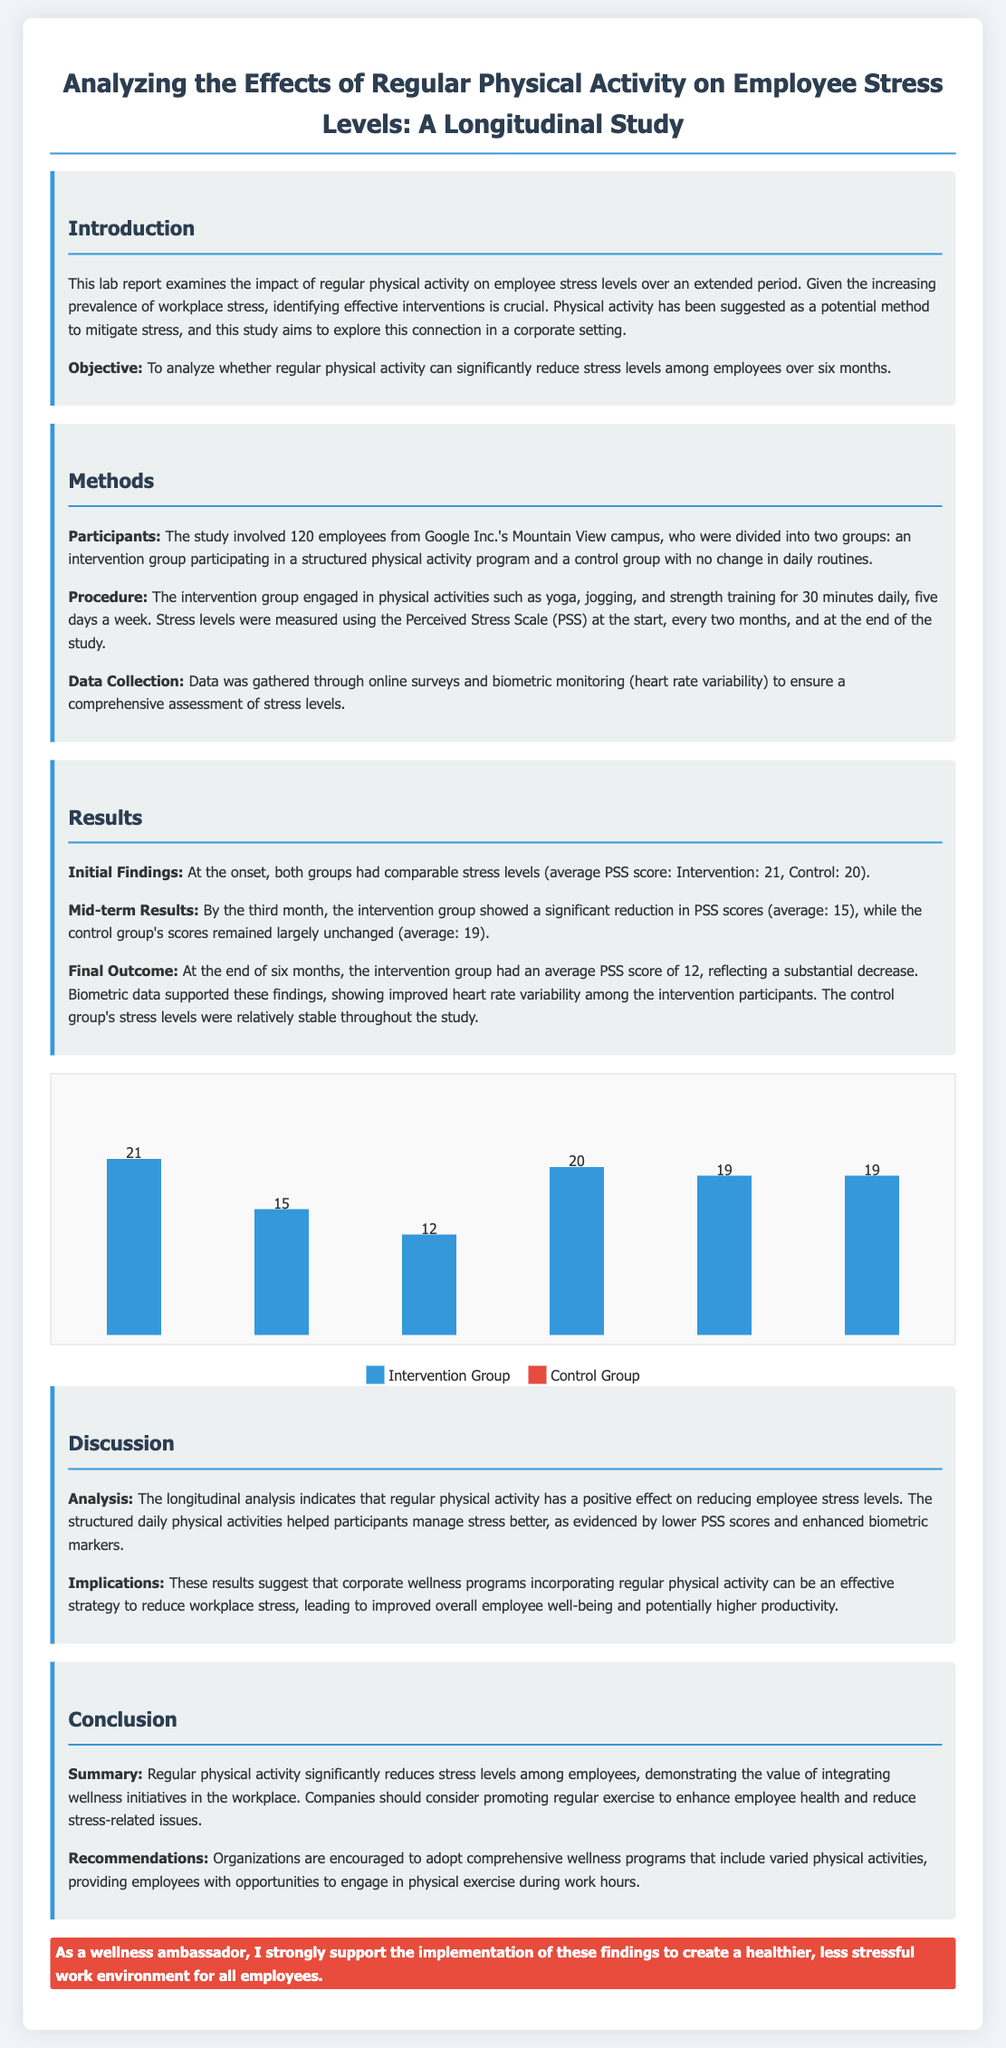What is the objective of the study? The objective is to analyze whether regular physical activity can significantly reduce stress levels among employees over six months.
Answer: To analyze whether regular physical activity can significantly reduce stress levels among employees over six months How many employees participated in the study? The study involved 120 employees from Google Inc.'s Mountain View campus.
Answer: 120 employees What was the average PSS score of the intervention group at the start? At the onset, the average PSS score for the intervention group was 21.
Answer: 21 What physical activities were included in the intervention? The intervention group engaged in Yoga, jogging, and strength training.
Answer: Yoga, jogging, and strength training What was the final average PSS score for the intervention group? At the end of six months, the intervention group had an average PSS score of 12.
Answer: 12 What effect did the study suggest about corporate wellness programs? The study suggests that corporate wellness programs incorporating regular physical activity can reduce workplace stress.
Answer: Reduce workplace stress What is the main finding of the longitudinal analysis? The longitudinal analysis indicates that regular physical activity has a positive effect on reducing employee stress levels.
Answer: Positive effect on reducing employee stress levels What type of data was collected for stress level assessment? Data was gathered through online surveys and biometric monitoring.
Answer: Online surveys and biometric monitoring 